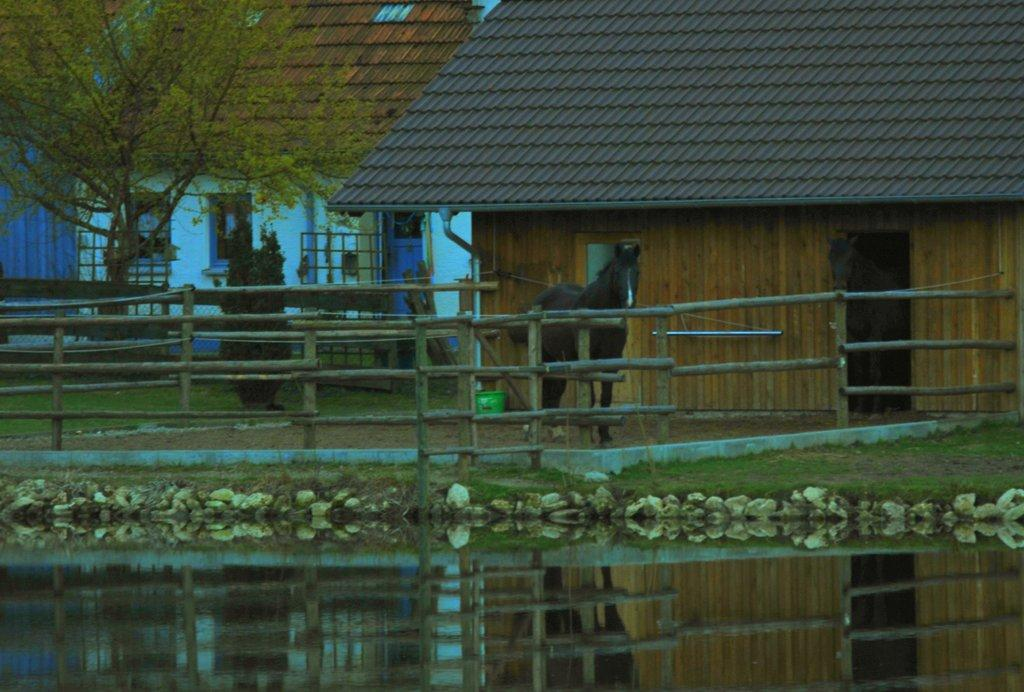What is the main subject in the middle of the image? There is a horse in the middle of the image. What is in front of the horse? There is a wooden fence in front of the horse. What can be seen in the image besides the horse and fence? Water is visible in the image, and there are houses and a tree in the background. What type of glue is being used to connect the bricks in the image? There are no bricks or glue present in the image; it features a horse with a wooden fence and a background with water, houses, and a tree. 